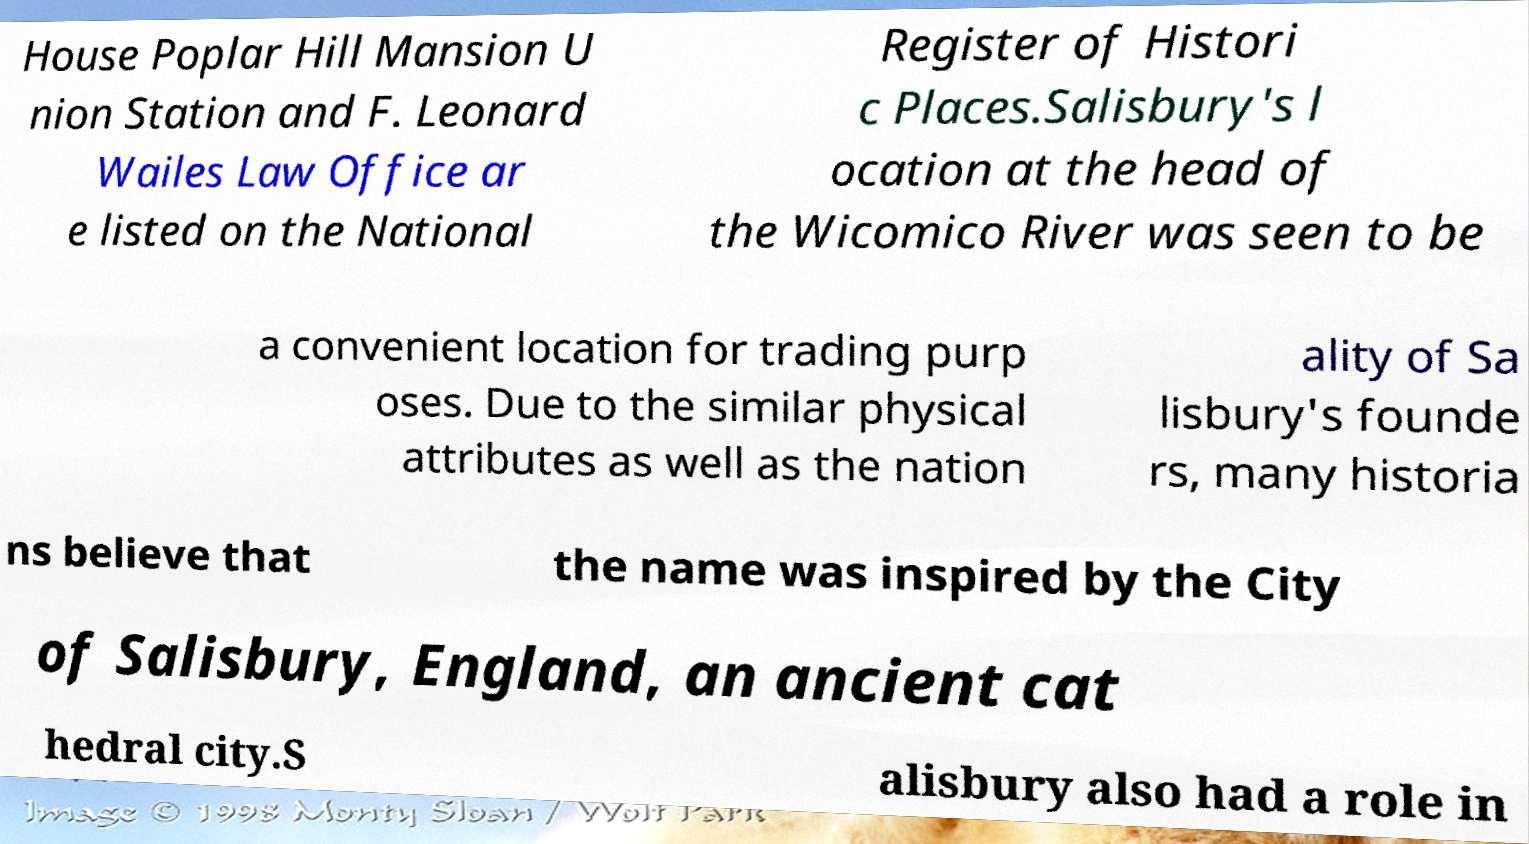Could you assist in decoding the text presented in this image and type it out clearly? House Poplar Hill Mansion U nion Station and F. Leonard Wailes Law Office ar e listed on the National Register of Histori c Places.Salisbury's l ocation at the head of the Wicomico River was seen to be a convenient location for trading purp oses. Due to the similar physical attributes as well as the nation ality of Sa lisbury's founde rs, many historia ns believe that the name was inspired by the City of Salisbury, England, an ancient cat hedral city.S alisbury also had a role in 